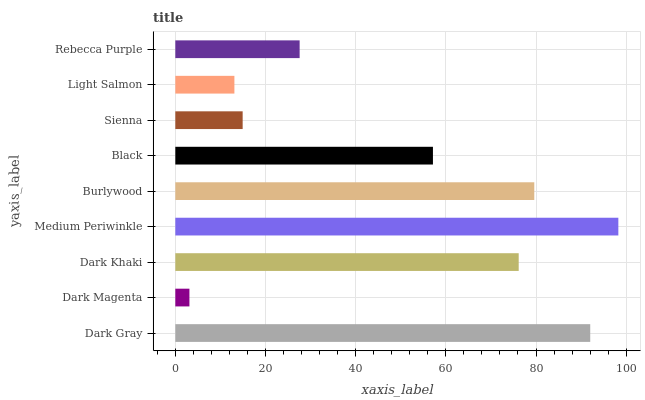Is Dark Magenta the minimum?
Answer yes or no. Yes. Is Medium Periwinkle the maximum?
Answer yes or no. Yes. Is Dark Khaki the minimum?
Answer yes or no. No. Is Dark Khaki the maximum?
Answer yes or no. No. Is Dark Khaki greater than Dark Magenta?
Answer yes or no. Yes. Is Dark Magenta less than Dark Khaki?
Answer yes or no. Yes. Is Dark Magenta greater than Dark Khaki?
Answer yes or no. No. Is Dark Khaki less than Dark Magenta?
Answer yes or no. No. Is Black the high median?
Answer yes or no. Yes. Is Black the low median?
Answer yes or no. Yes. Is Burlywood the high median?
Answer yes or no. No. Is Burlywood the low median?
Answer yes or no. No. 